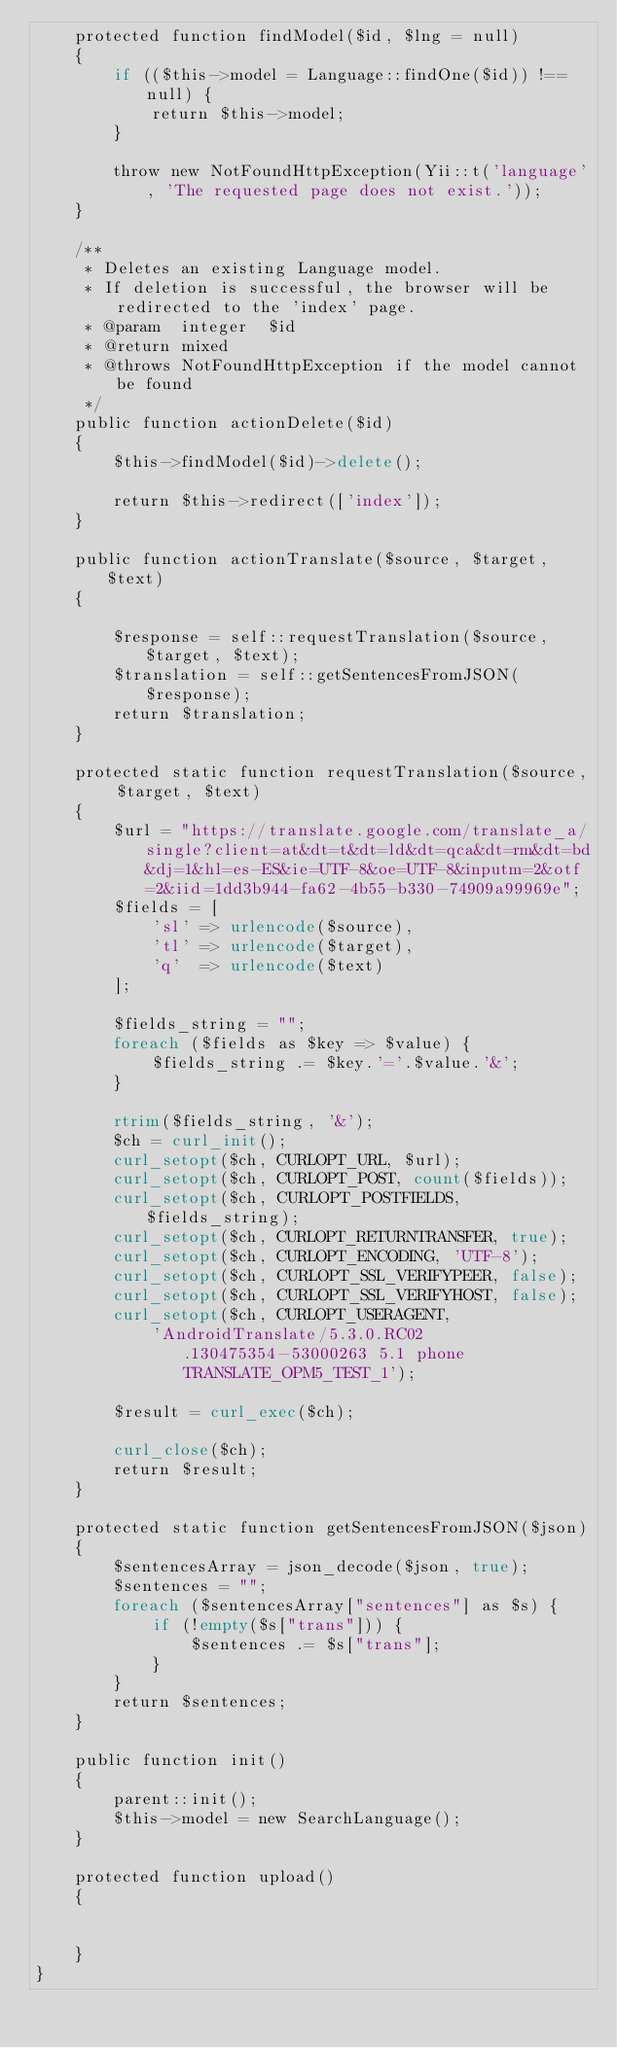<code> <loc_0><loc_0><loc_500><loc_500><_PHP_>    protected function findModel($id, $lng = null)
    {
        if (($this->model = Language::findOne($id)) !== null) {
            return $this->model;
        }

        throw new NotFoundHttpException(Yii::t('language', 'The requested page does not exist.'));
    }

    /**
     * Deletes an existing Language model.
     * If deletion is successful, the browser will be redirected to the 'index' page.
     * @param  integer  $id
     * @return mixed
     * @throws NotFoundHttpException if the model cannot be found
     */
    public function actionDelete($id)
    {
        $this->findModel($id)->delete();

        return $this->redirect(['index']);
    }

    public function actionTranslate($source, $target, $text)
    {

        $response = self::requestTranslation($source, $target, $text);
        $translation = self::getSentencesFromJSON($response);
        return $translation;
    }

    protected static function requestTranslation($source, $target, $text)
    {
        $url = "https://translate.google.com/translate_a/single?client=at&dt=t&dt=ld&dt=qca&dt=rm&dt=bd&dj=1&hl=es-ES&ie=UTF-8&oe=UTF-8&inputm=2&otf=2&iid=1dd3b944-fa62-4b55-b330-74909a99969e";
        $fields = [
            'sl' => urlencode($source),
            'tl' => urlencode($target),
            'q'  => urlencode($text)
        ];

        $fields_string = "";
        foreach ($fields as $key => $value) {
            $fields_string .= $key.'='.$value.'&';
        }

        rtrim($fields_string, '&');
        $ch = curl_init();
        curl_setopt($ch, CURLOPT_URL, $url);
        curl_setopt($ch, CURLOPT_POST, count($fields));
        curl_setopt($ch, CURLOPT_POSTFIELDS, $fields_string);
        curl_setopt($ch, CURLOPT_RETURNTRANSFER, true);
        curl_setopt($ch, CURLOPT_ENCODING, 'UTF-8');
        curl_setopt($ch, CURLOPT_SSL_VERIFYPEER, false);
        curl_setopt($ch, CURLOPT_SSL_VERIFYHOST, false);
        curl_setopt($ch, CURLOPT_USERAGENT,
            'AndroidTranslate/5.3.0.RC02.130475354-53000263 5.1 phone TRANSLATE_OPM5_TEST_1');

        $result = curl_exec($ch);

        curl_close($ch);
        return $result;
    }

    protected static function getSentencesFromJSON($json)
    {
        $sentencesArray = json_decode($json, true);
        $sentences = "";
        foreach ($sentencesArray["sentences"] as $s) {
            if (!empty($s["trans"])) {
                $sentences .= $s["trans"];
            }
        }
        return $sentences;
    }

    public function init()
    {
        parent::init();
        $this->model = new SearchLanguage();
    }

    protected function upload()
    {


    }
}
</code> 